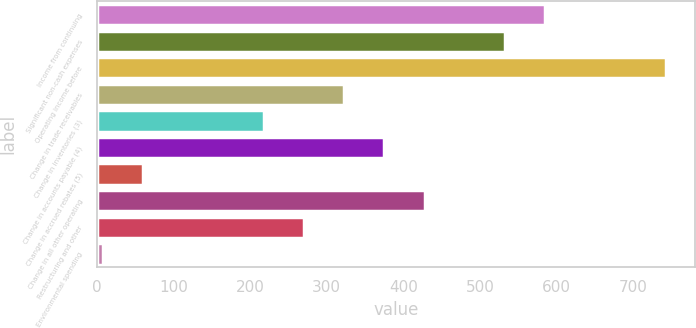Convert chart to OTSL. <chart><loc_0><loc_0><loc_500><loc_500><bar_chart><fcel>Income from continuing<fcel>Significant non-cash expenses<fcel>Operating income before<fcel>Change in trade receivables<fcel>Change in inventories (3)<fcel>Change in accounts payable (4)<fcel>Change in accrued rebates (5)<fcel>Change in all other operating<fcel>Restructuring and other<fcel>Environmental spending<nl><fcel>585.45<fcel>532.9<fcel>743.1<fcel>322.7<fcel>217.6<fcel>375.25<fcel>59.95<fcel>427.8<fcel>270.15<fcel>7.4<nl></chart> 